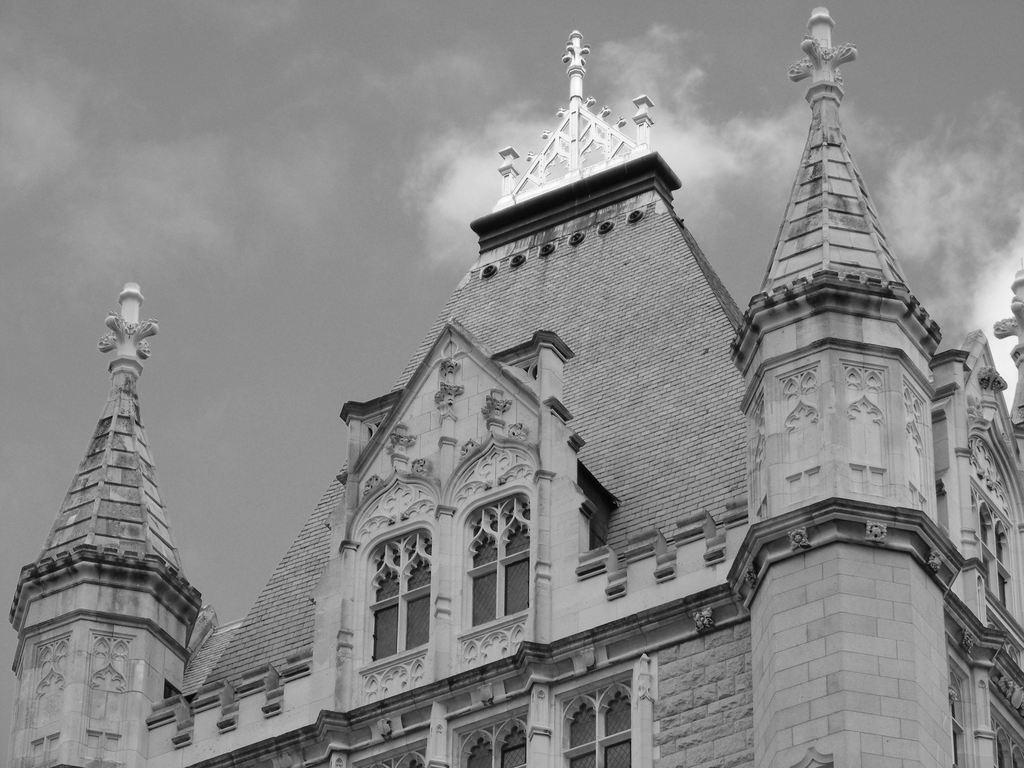Can you describe this image briefly? In this picture we can see a building with windows and in the background we can see the sky. 